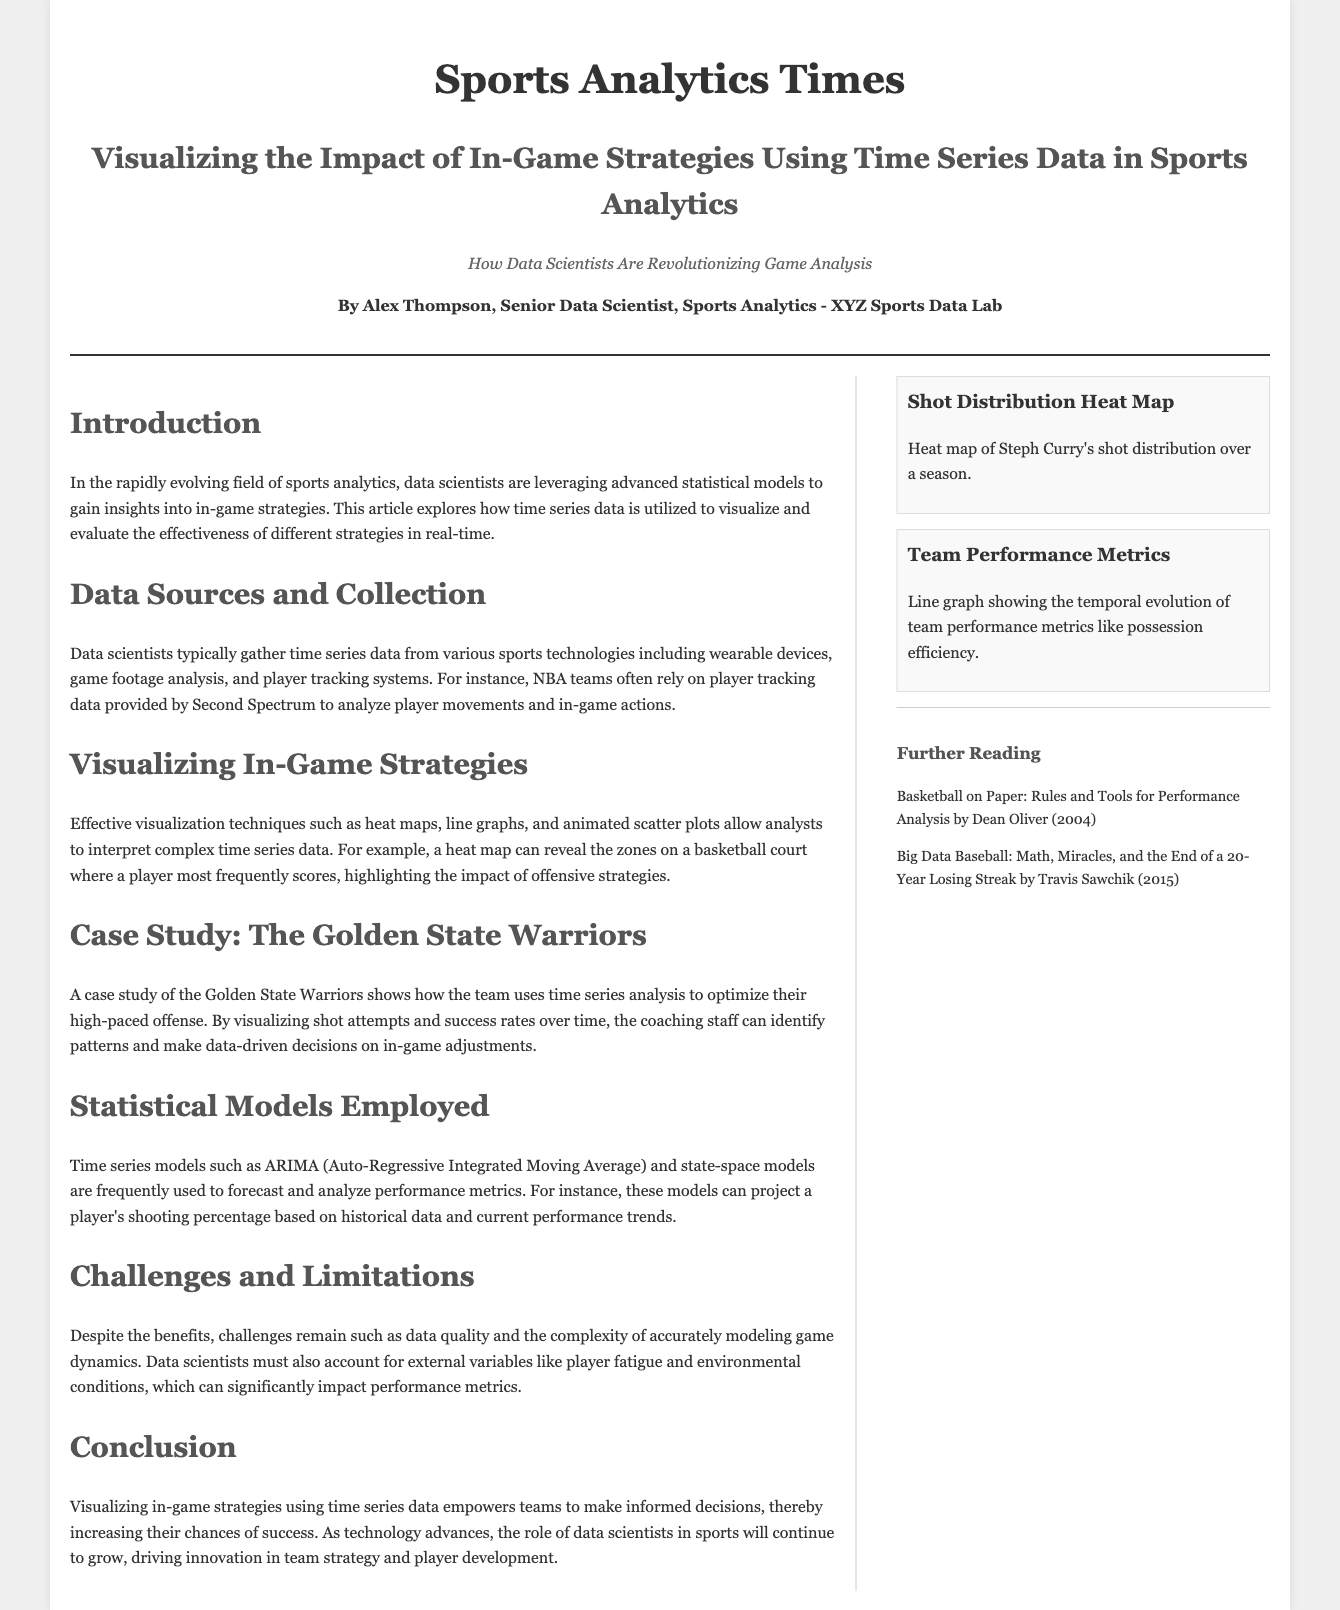What is the title of the article? The title of the article is stated at the top of the document, summarizing the theme of the content.
Answer: Visualizing the Impact of In-Game Strategies Using Time Series Data in Sports Analytics Who is the author of the article? The author is introduced in the header section, showcasing their role and affiliation.
Answer: Alex Thompson What type of data do data scientists typically gather? The document mentions that time series data is commonly collected from various sports technologies.
Answer: Time series data Which team is used as a case study in the article? The article refers to a specific team to illustrate the concepts discussed, highlighted in a dedicated section.
Answer: The Golden State Warriors What statistical models are mentioned in the article? The text lists particular time series models utilized in sports analytics, showing their relevance to the discussion.
Answer: ARIMA and state-space models What challenge do data scientists face according to the article? The challenges discussed in the article address issues that impact the effectiveness of data analysis in sports.
Answer: Data quality How does visualization aid analysts according to the document? The document details how visualization techniques help in interpreting complex data related to in-game strategies.
Answer: Interpret complex time series data What is said to empower teams to make informed decisions? The conclusion of the document emphasizes the role of a specific type of data analysis in aiding strategic decisions.
Answer: Visualizing in-game strategies using time series data 